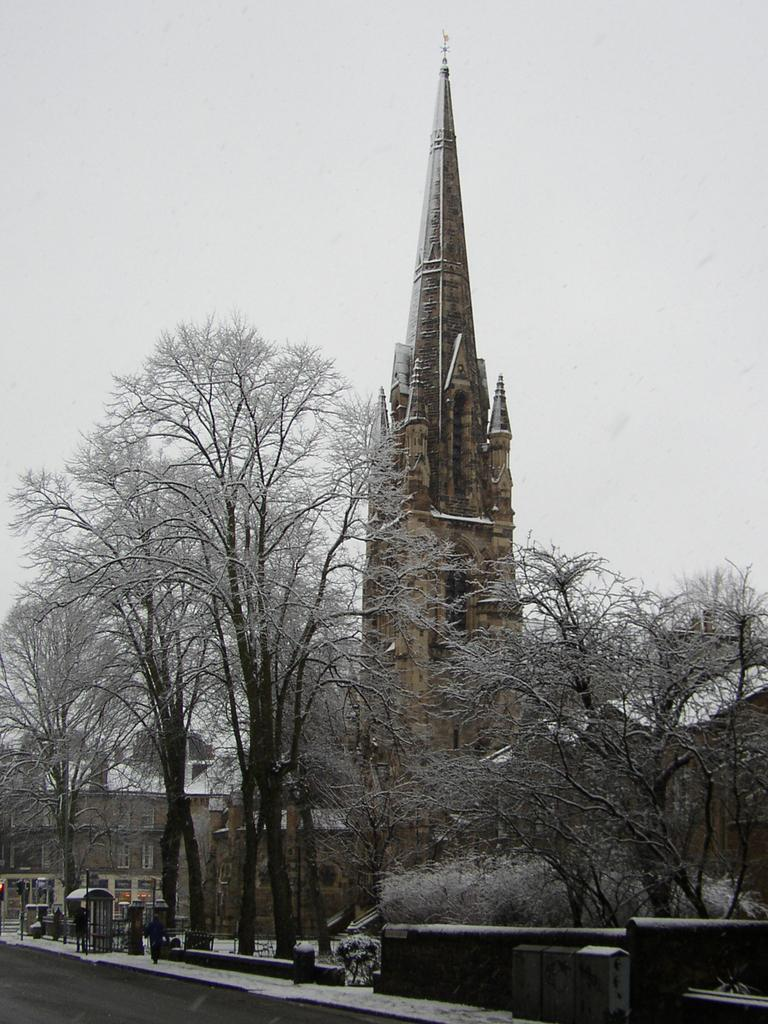What type of structures can be seen in the image? There are buildings in the image. What other natural elements are present in the image? There are trees in the image. What can be seen on the road in the image? There are booths and people walking on the road in the image. What is visible in the background of the image? The sky is visible in the image. Is there a volcano visible in the image? No, there is no volcano present in the image. What type of harmony can be heard in the image? There is no sound or music in the image, so it's not possible to determine the type of harmony. 